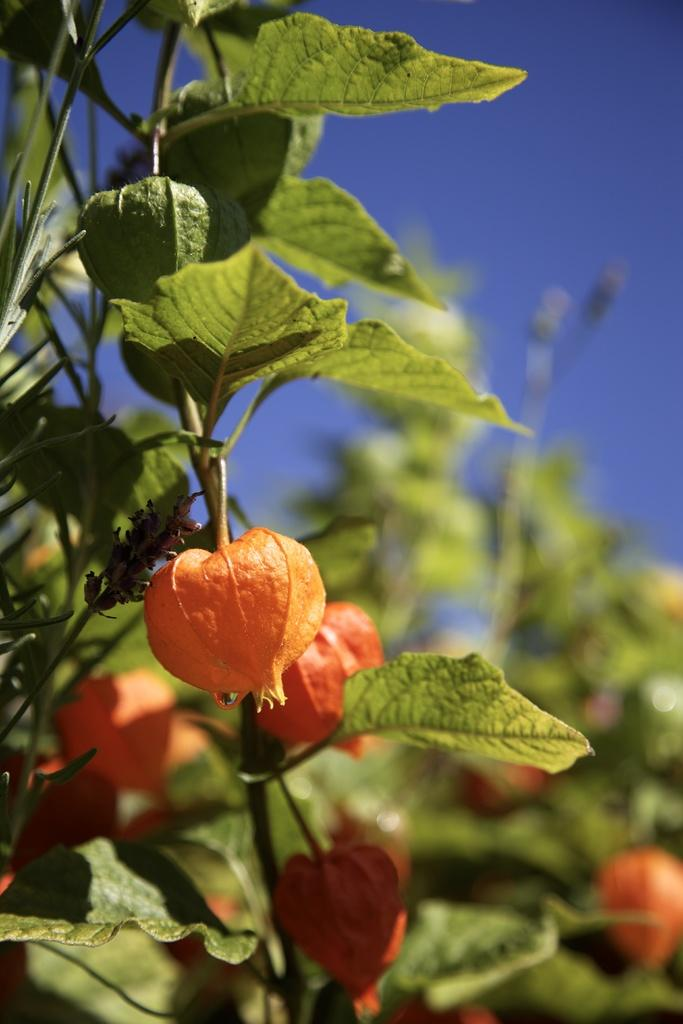What color are the flowers in the image? The flowers in the image are orange. Where are the flowers located? The flowers are on plants. What is visible at the top of the image? The sky is visible at the top of the image. How many children are holding mittens in the image? There are no children or mittens present in the image. What type of star can be seen in the image? There is no star visible in the image; only flowers, plants, and the sky are present. 